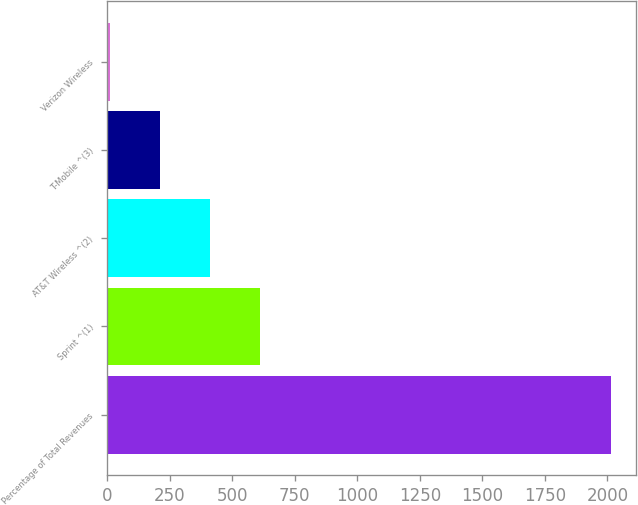Convert chart. <chart><loc_0><loc_0><loc_500><loc_500><bar_chart><fcel>Percentage of Total Revenues<fcel>Sprint ^(1)<fcel>AT&T Wireless ^(2)<fcel>T-Mobile ^(3)<fcel>Verizon Wireless<nl><fcel>2014<fcel>612.6<fcel>412.4<fcel>212.2<fcel>12<nl></chart> 